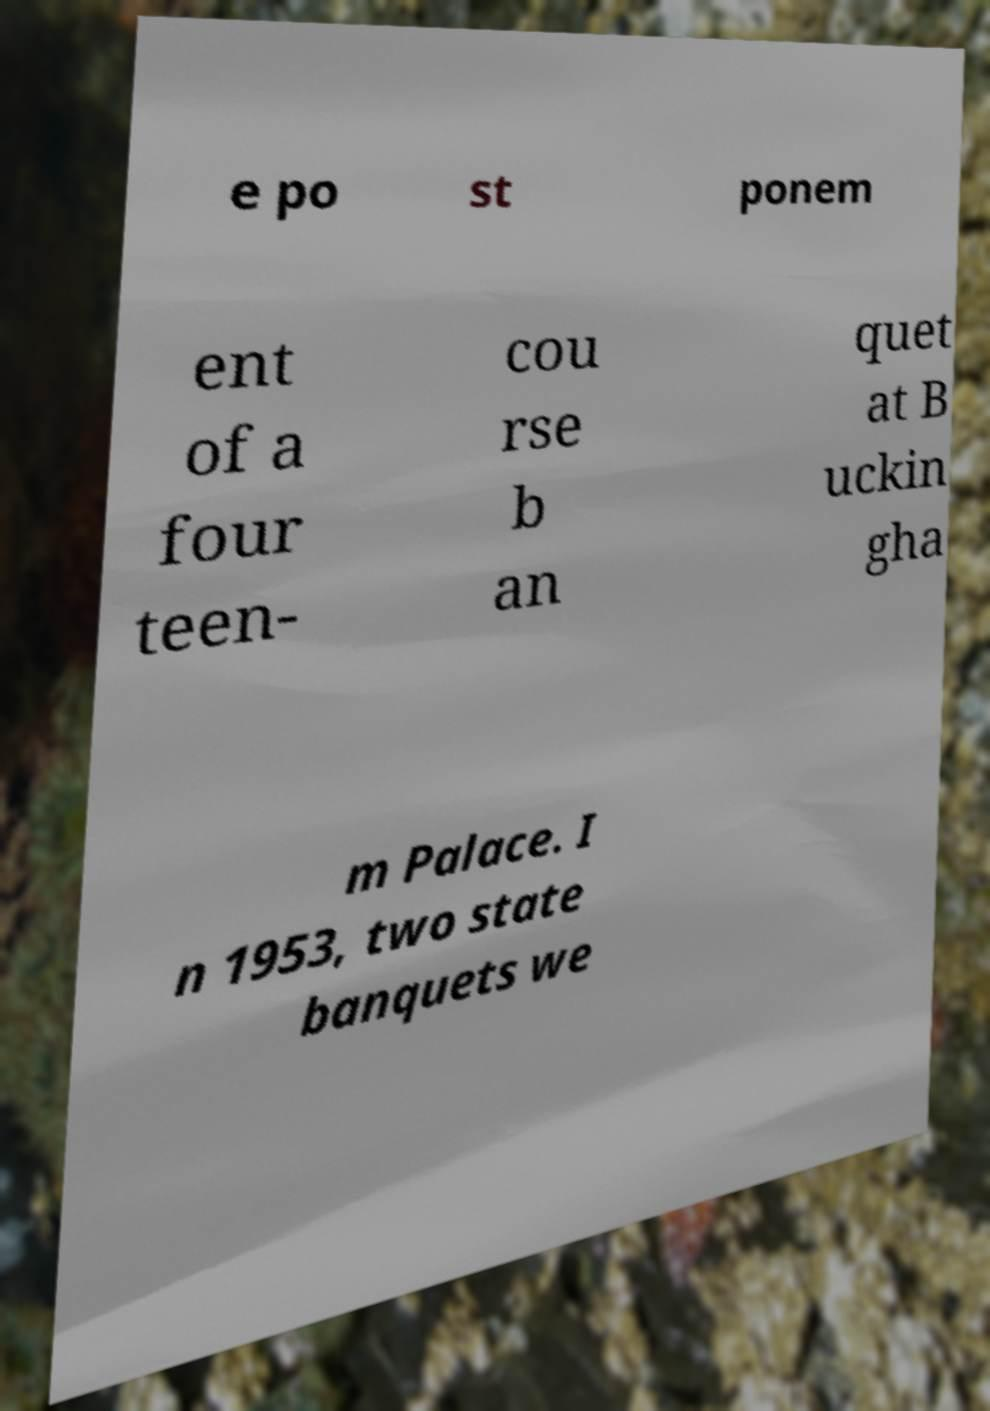Can you accurately transcribe the text from the provided image for me? e po st ponem ent of a four teen- cou rse b an quet at B uckin gha m Palace. I n 1953, two state banquets we 